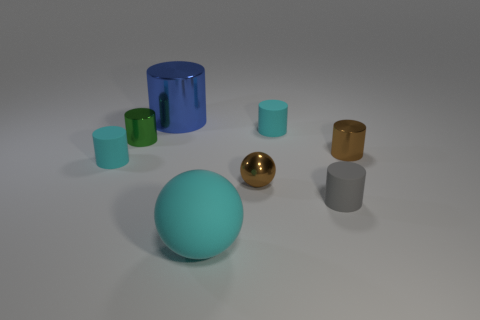Are there any yellow matte blocks that have the same size as the brown shiny cylinder?
Make the answer very short. No. Is the material of the small brown ball the same as the tiny cyan object that is right of the cyan matte sphere?
Provide a short and direct response. No. Are there more gray matte spheres than tiny green cylinders?
Make the answer very short. No. What number of cylinders are tiny rubber things or big metal objects?
Give a very brief answer. 4. What is the color of the metallic ball?
Your response must be concise. Brown. There is a cyan matte cylinder left of the small brown metallic sphere; does it have the same size as the cyan matte cylinder that is on the right side of the large metallic cylinder?
Keep it short and to the point. Yes. Are there fewer small gray cylinders than brown things?
Ensure brevity in your answer.  Yes. What number of tiny brown shiny spheres are behind the big cylinder?
Make the answer very short. 0. What is the material of the green cylinder?
Your answer should be compact. Metal. Is the big metal cylinder the same color as the small metal sphere?
Offer a terse response. No. 